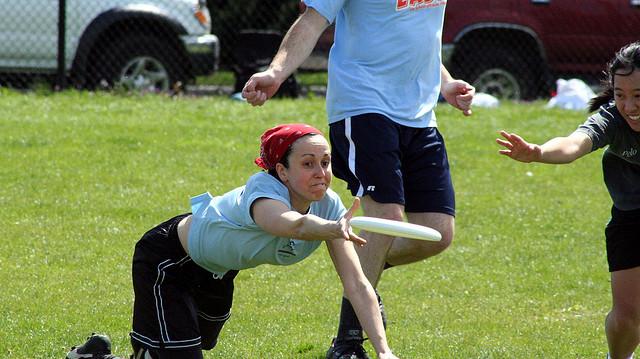What sport is being played?
Short answer required. Frisbee. Is a female catching the frisbee?
Quick response, please. Yes. How many vehicles are in the background?
Be succinct. 2. 